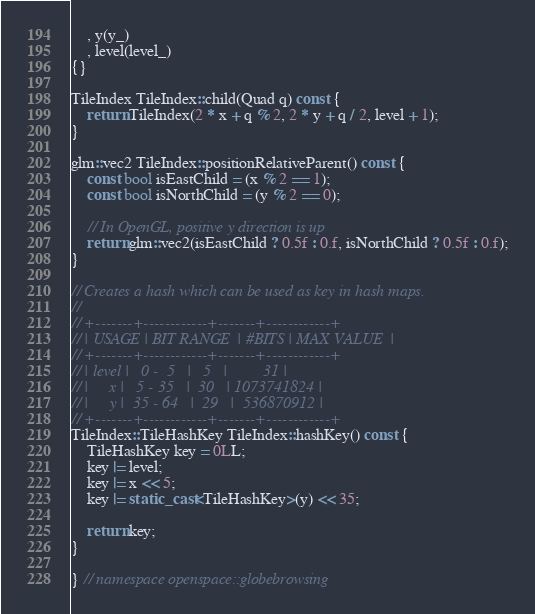Convert code to text. <code><loc_0><loc_0><loc_500><loc_500><_C++_>    , y(y_)
    , level(level_)
{}

TileIndex TileIndex::child(Quad q) const {
    return TileIndex(2 * x + q % 2, 2 * y + q / 2, level + 1);
}

glm::vec2 TileIndex::positionRelativeParent() const {
    const bool isEastChild = (x % 2 == 1);
    const bool isNorthChild = (y % 2 == 0);

    // In OpenGL, positive y direction is up
    return glm::vec2(isEastChild ? 0.5f : 0.f, isNorthChild ? 0.5f : 0.f);
}

// Creates a hash which can be used as key in hash maps.
//
// +-------+------------+-------+------------+
// | USAGE | BIT RANGE  | #BITS | MAX VALUE  |
// +-------+------------+-------+------------+
// | level |   0 -  5   |   5   |         31 |
// |     x |   5 - 35   |  30   | 1073741824 |
// |     y |  35 - 64   |  29   |  536870912 |
// +-------+------------+-------+------------+
TileIndex::TileHashKey TileIndex::hashKey() const {
    TileHashKey key = 0LL;
    key |= level;
    key |= x << 5;
    key |= static_cast<TileHashKey>(y) << 35;

    return key;
}

} // namespace openspace::globebrowsing
</code> 